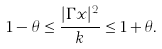<formula> <loc_0><loc_0><loc_500><loc_500>1 - \theta \leq \frac { | \Gamma x | ^ { 2 } } { k } \leq 1 + \theta .</formula> 